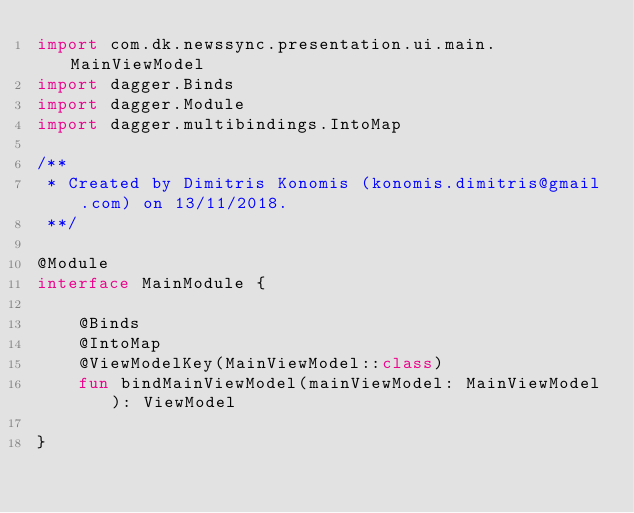Convert code to text. <code><loc_0><loc_0><loc_500><loc_500><_Kotlin_>import com.dk.newssync.presentation.ui.main.MainViewModel
import dagger.Binds
import dagger.Module
import dagger.multibindings.IntoMap

/**
 * Created by Dimitris Konomis (konomis.dimitris@gmail.com) on 13/11/2018.
 **/

@Module
interface MainModule {

    @Binds
    @IntoMap
    @ViewModelKey(MainViewModel::class)
    fun bindMainViewModel(mainViewModel: MainViewModel): ViewModel

}</code> 